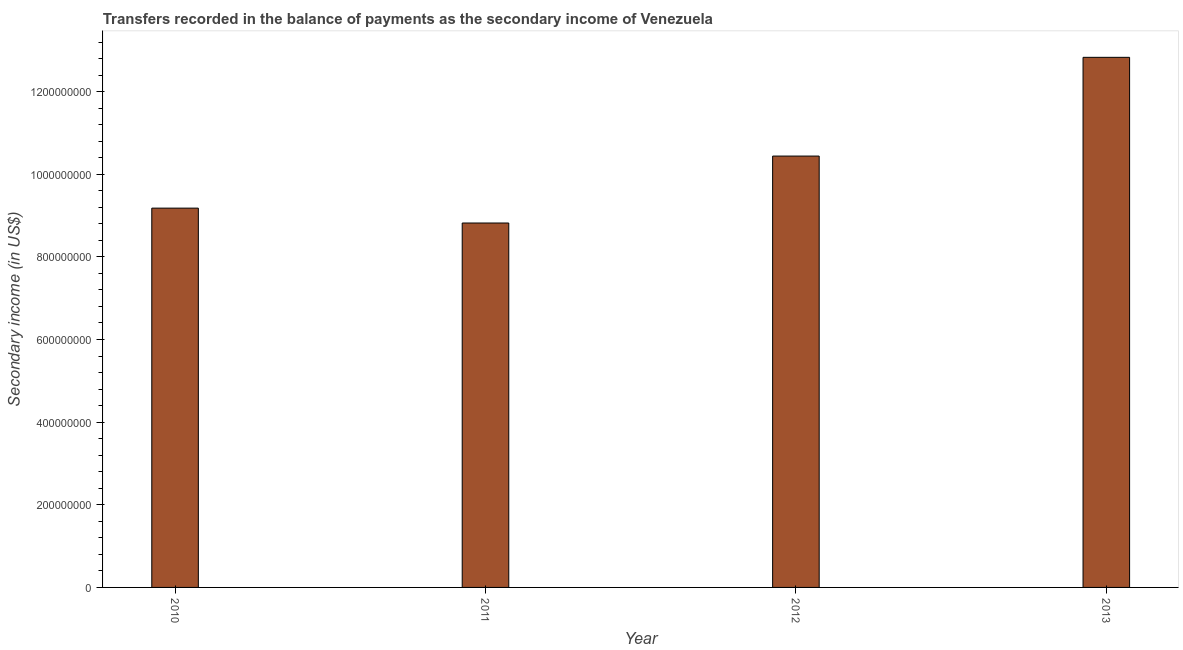Does the graph contain any zero values?
Provide a short and direct response. No. What is the title of the graph?
Provide a short and direct response. Transfers recorded in the balance of payments as the secondary income of Venezuela. What is the label or title of the Y-axis?
Keep it short and to the point. Secondary income (in US$). What is the amount of secondary income in 2012?
Provide a succinct answer. 1.04e+09. Across all years, what is the maximum amount of secondary income?
Ensure brevity in your answer.  1.28e+09. Across all years, what is the minimum amount of secondary income?
Your answer should be compact. 8.82e+08. In which year was the amount of secondary income maximum?
Provide a short and direct response. 2013. What is the sum of the amount of secondary income?
Give a very brief answer. 4.13e+09. What is the difference between the amount of secondary income in 2010 and 2011?
Offer a very short reply. 3.60e+07. What is the average amount of secondary income per year?
Make the answer very short. 1.03e+09. What is the median amount of secondary income?
Your answer should be very brief. 9.81e+08. What is the ratio of the amount of secondary income in 2010 to that in 2011?
Provide a succinct answer. 1.04. Is the difference between the amount of secondary income in 2011 and 2012 greater than the difference between any two years?
Offer a terse response. No. What is the difference between the highest and the second highest amount of secondary income?
Your response must be concise. 2.39e+08. What is the difference between the highest and the lowest amount of secondary income?
Provide a succinct answer. 4.01e+08. What is the Secondary income (in US$) of 2010?
Offer a terse response. 9.18e+08. What is the Secondary income (in US$) of 2011?
Your answer should be very brief. 8.82e+08. What is the Secondary income (in US$) in 2012?
Ensure brevity in your answer.  1.04e+09. What is the Secondary income (in US$) of 2013?
Your answer should be compact. 1.28e+09. What is the difference between the Secondary income (in US$) in 2010 and 2011?
Ensure brevity in your answer.  3.60e+07. What is the difference between the Secondary income (in US$) in 2010 and 2012?
Keep it short and to the point. -1.26e+08. What is the difference between the Secondary income (in US$) in 2010 and 2013?
Offer a very short reply. -3.65e+08. What is the difference between the Secondary income (in US$) in 2011 and 2012?
Your response must be concise. -1.62e+08. What is the difference between the Secondary income (in US$) in 2011 and 2013?
Your response must be concise. -4.01e+08. What is the difference between the Secondary income (in US$) in 2012 and 2013?
Your response must be concise. -2.39e+08. What is the ratio of the Secondary income (in US$) in 2010 to that in 2011?
Keep it short and to the point. 1.04. What is the ratio of the Secondary income (in US$) in 2010 to that in 2012?
Give a very brief answer. 0.88. What is the ratio of the Secondary income (in US$) in 2010 to that in 2013?
Keep it short and to the point. 0.72. What is the ratio of the Secondary income (in US$) in 2011 to that in 2012?
Offer a very short reply. 0.84. What is the ratio of the Secondary income (in US$) in 2011 to that in 2013?
Offer a terse response. 0.69. What is the ratio of the Secondary income (in US$) in 2012 to that in 2013?
Keep it short and to the point. 0.81. 